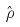Convert formula to latex. <formula><loc_0><loc_0><loc_500><loc_500>\hat { \rho }</formula> 